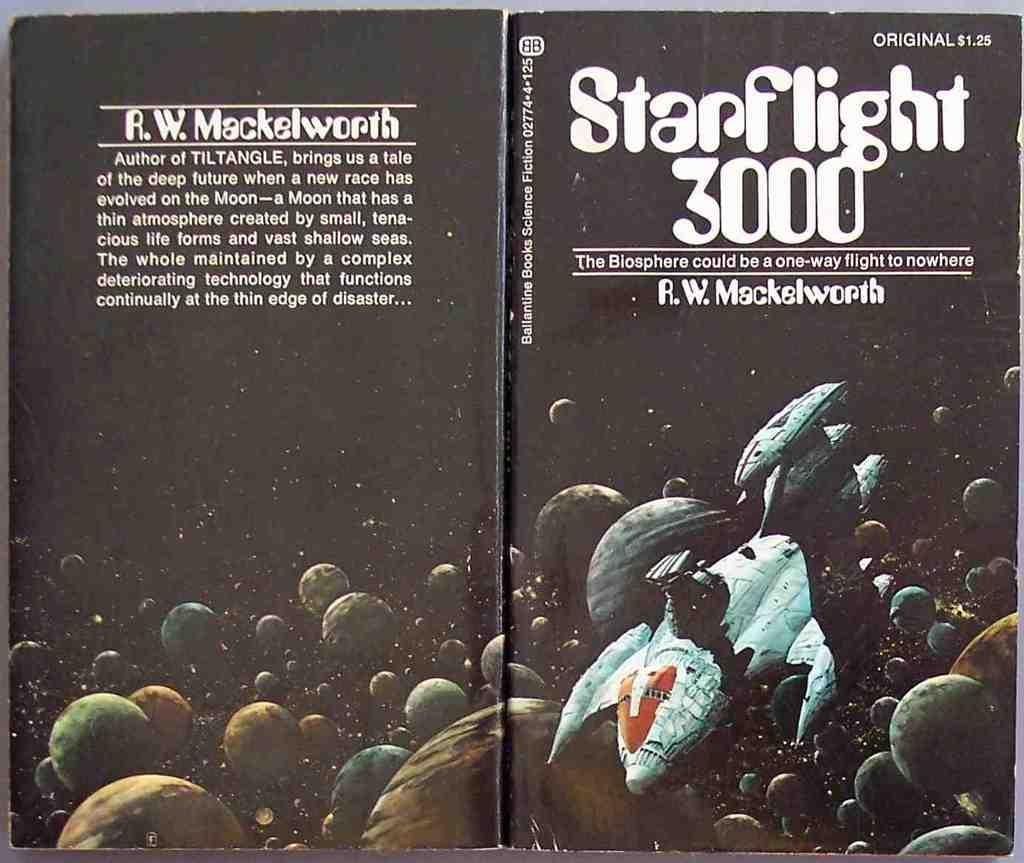<image>
Render a clear and concise summary of the photo. A black space book called Starflight 3000 is laid open 